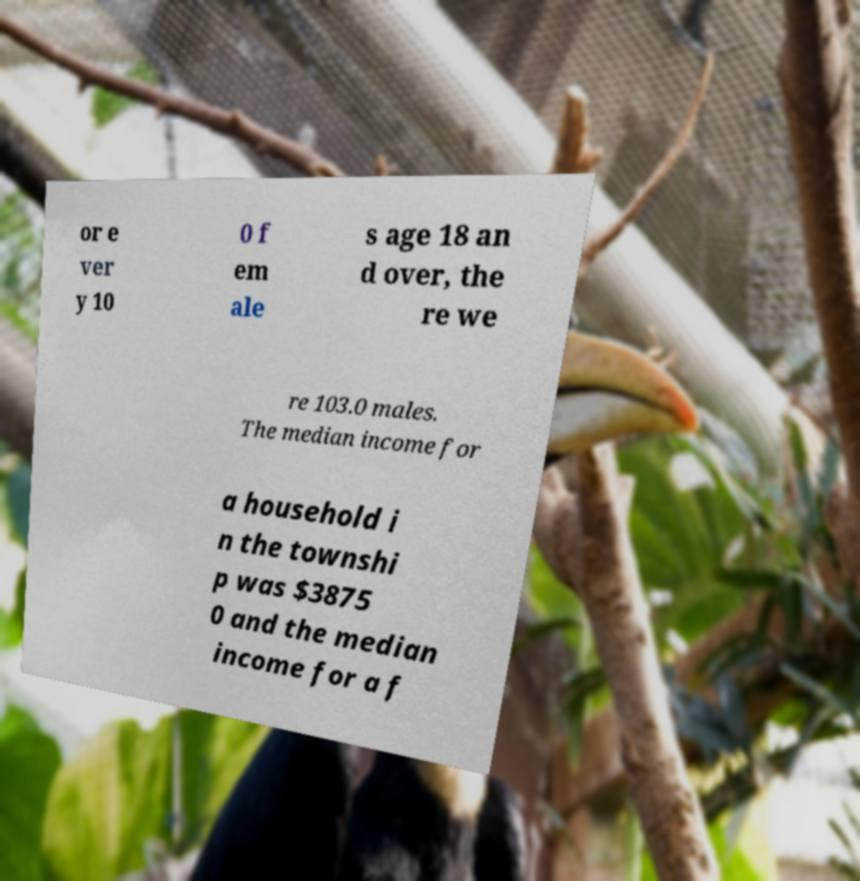I need the written content from this picture converted into text. Can you do that? or e ver y 10 0 f em ale s age 18 an d over, the re we re 103.0 males. The median income for a household i n the townshi p was $3875 0 and the median income for a f 